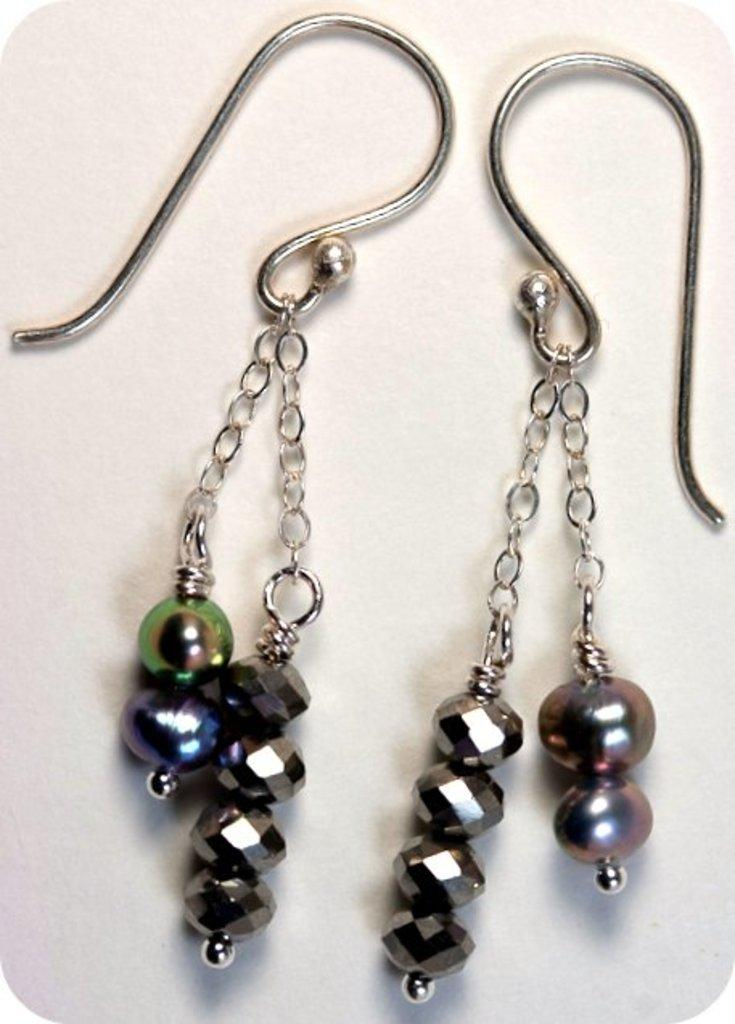What type of jewelry is visible in the image? There are earrings in the image. Where are the earrings located? The earrings are on a surface. What type of flooring can be seen beneath the earrings in the image? There is no flooring visible in the image; only the earrings and the surface they are on are present. 